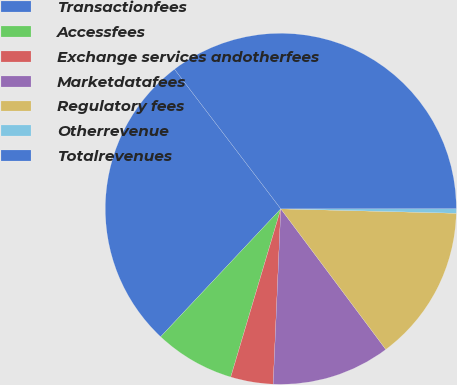<chart> <loc_0><loc_0><loc_500><loc_500><pie_chart><fcel>Transactionfees<fcel>Accessfees<fcel>Exchange services andotherfees<fcel>Marketdatafees<fcel>Regulatory fees<fcel>Otherrevenue<fcel>Totalrevenues<nl><fcel>27.64%<fcel>7.4%<fcel>3.91%<fcel>10.9%<fcel>14.39%<fcel>0.42%<fcel>35.34%<nl></chart> 